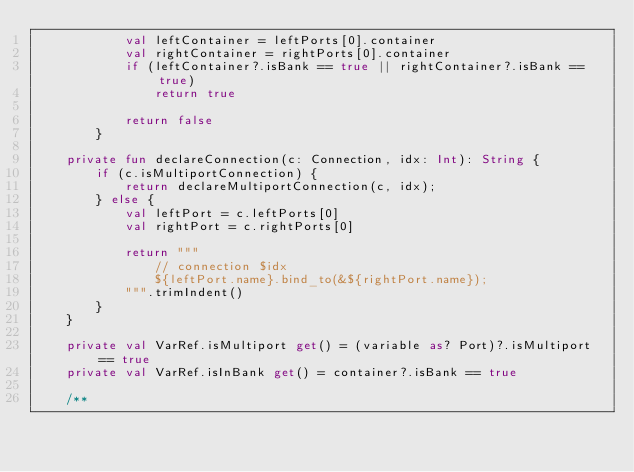<code> <loc_0><loc_0><loc_500><loc_500><_Kotlin_>            val leftContainer = leftPorts[0].container
            val rightContainer = rightPorts[0].container
            if (leftContainer?.isBank == true || rightContainer?.isBank == true)
                return true

            return false
        }

    private fun declareConnection(c: Connection, idx: Int): String {
        if (c.isMultiportConnection) {
            return declareMultiportConnection(c, idx);
        } else {
            val leftPort = c.leftPorts[0]
            val rightPort = c.rightPorts[0]

            return """
                // connection $idx
                ${leftPort.name}.bind_to(&${rightPort.name});
            """.trimIndent()
        }
    }

    private val VarRef.isMultiport get() = (variable as? Port)?.isMultiport == true
    private val VarRef.isInBank get() = container?.isBank == true

    /**</code> 